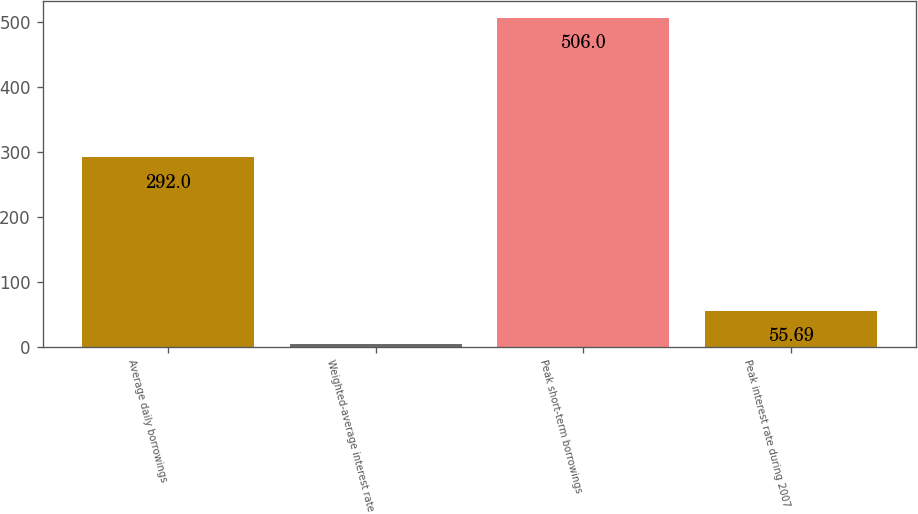Convert chart to OTSL. <chart><loc_0><loc_0><loc_500><loc_500><bar_chart><fcel>Average daily borrowings<fcel>Weighted-average interest rate<fcel>Peak short-term borrowings<fcel>Peak interest rate during 2007<nl><fcel>292<fcel>5.66<fcel>506<fcel>55.69<nl></chart> 